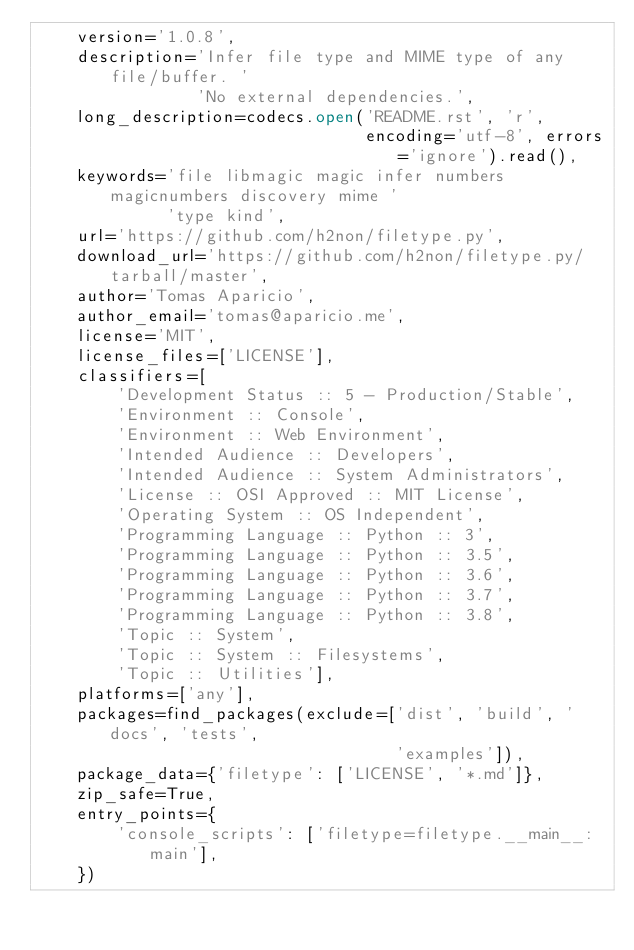<code> <loc_0><loc_0><loc_500><loc_500><_Python_>    version='1.0.8',
    description='Infer file type and MIME type of any file/buffer. '
                'No external dependencies.',
    long_description=codecs.open('README.rst', 'r',
                                 encoding='utf-8', errors='ignore').read(),
    keywords='file libmagic magic infer numbers magicnumbers discovery mime '
             'type kind',
    url='https://github.com/h2non/filetype.py',
    download_url='https://github.com/h2non/filetype.py/tarball/master',
    author='Tomas Aparicio',
    author_email='tomas@aparicio.me',
    license='MIT',
    license_files=['LICENSE'],
    classifiers=[
        'Development Status :: 5 - Production/Stable',
        'Environment :: Console',
        'Environment :: Web Environment',
        'Intended Audience :: Developers',
        'Intended Audience :: System Administrators',
        'License :: OSI Approved :: MIT License',
        'Operating System :: OS Independent',
        'Programming Language :: Python :: 3',
        'Programming Language :: Python :: 3.5',
        'Programming Language :: Python :: 3.6',
        'Programming Language :: Python :: 3.7',
        'Programming Language :: Python :: 3.8',
        'Topic :: System',
        'Topic :: System :: Filesystems',
        'Topic :: Utilities'],
    platforms=['any'],
    packages=find_packages(exclude=['dist', 'build', 'docs', 'tests',
                                    'examples']),
    package_data={'filetype': ['LICENSE', '*.md']},
    zip_safe=True,
    entry_points={
        'console_scripts': ['filetype=filetype.__main__:main'],
    })
</code> 